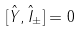<formula> <loc_0><loc_0><loc_500><loc_500>[ \hat { Y } , \hat { I } _ { \pm } ] = 0</formula> 